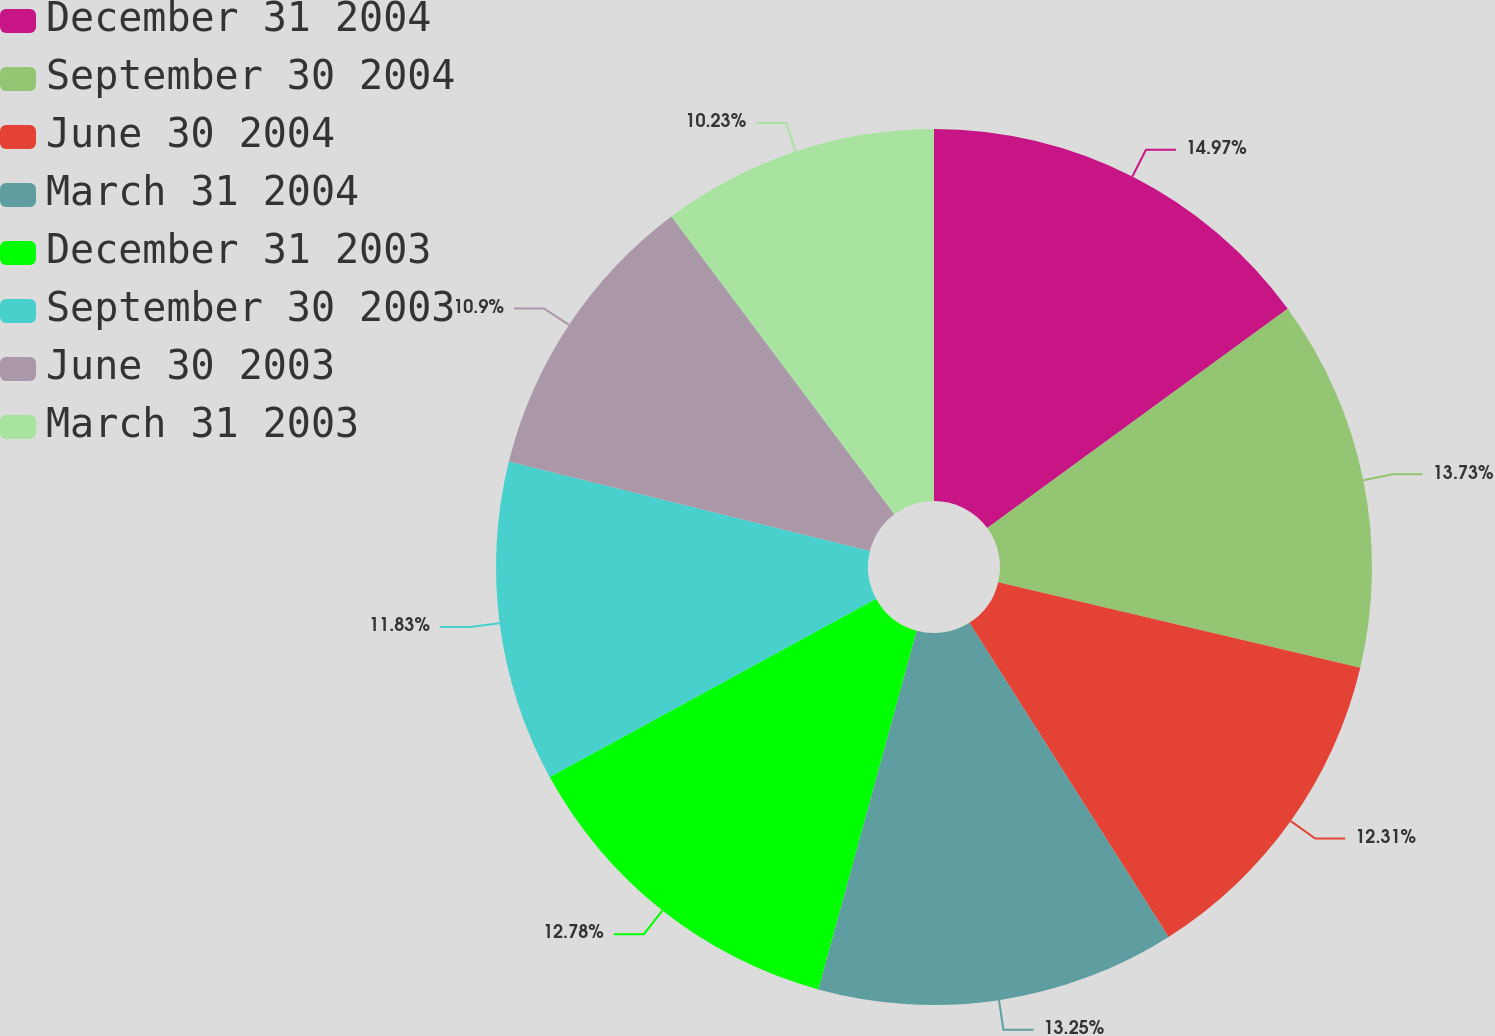<chart> <loc_0><loc_0><loc_500><loc_500><pie_chart><fcel>December 31 2004<fcel>September 30 2004<fcel>June 30 2004<fcel>March 31 2004<fcel>December 31 2003<fcel>September 30 2003<fcel>June 30 2003<fcel>March 31 2003<nl><fcel>14.96%<fcel>13.73%<fcel>12.31%<fcel>13.25%<fcel>12.78%<fcel>11.83%<fcel>10.9%<fcel>10.23%<nl></chart> 